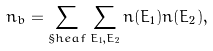<formula> <loc_0><loc_0><loc_500><loc_500>n _ { b } = \sum _ { \S h e a f } \sum _ { E _ { 1 } , E _ { 2 } } n ( E _ { 1 } ) n ( E _ { 2 } ) ,</formula> 